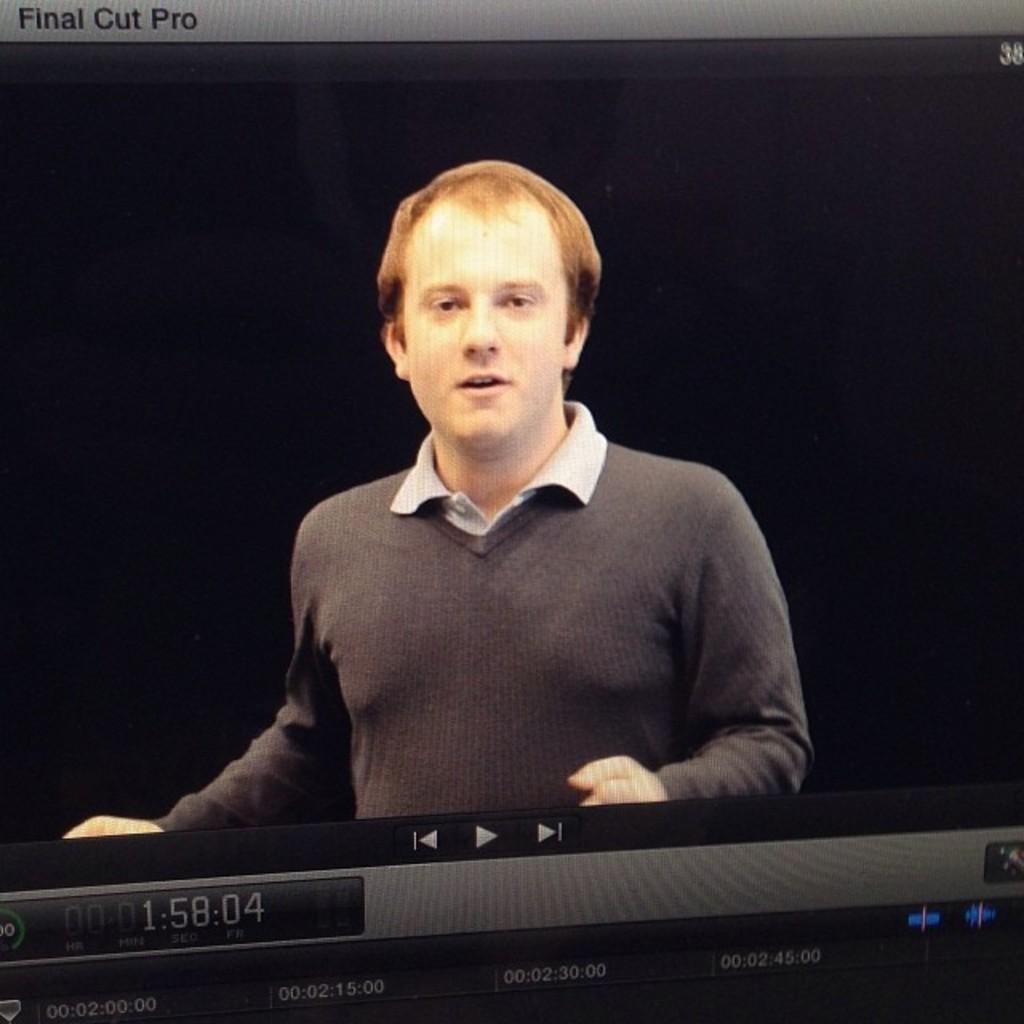How would you summarize this image in a sentence or two? In this image there is a screen in which we can see a person. 